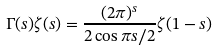Convert formula to latex. <formula><loc_0><loc_0><loc_500><loc_500>\Gamma ( s ) \zeta ( s ) = \frac { ( 2 \pi ) ^ { s } } { 2 \cos \pi s / 2 } \zeta ( 1 - s )</formula> 